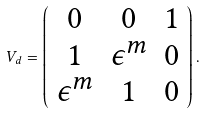<formula> <loc_0><loc_0><loc_500><loc_500>V _ { d } = \left ( \begin{array} { c c c } 0 & 0 & 1 \\ 1 & \epsilon ^ { m } & 0 \\ \epsilon ^ { m } & 1 & 0 \end{array} \right ) .</formula> 